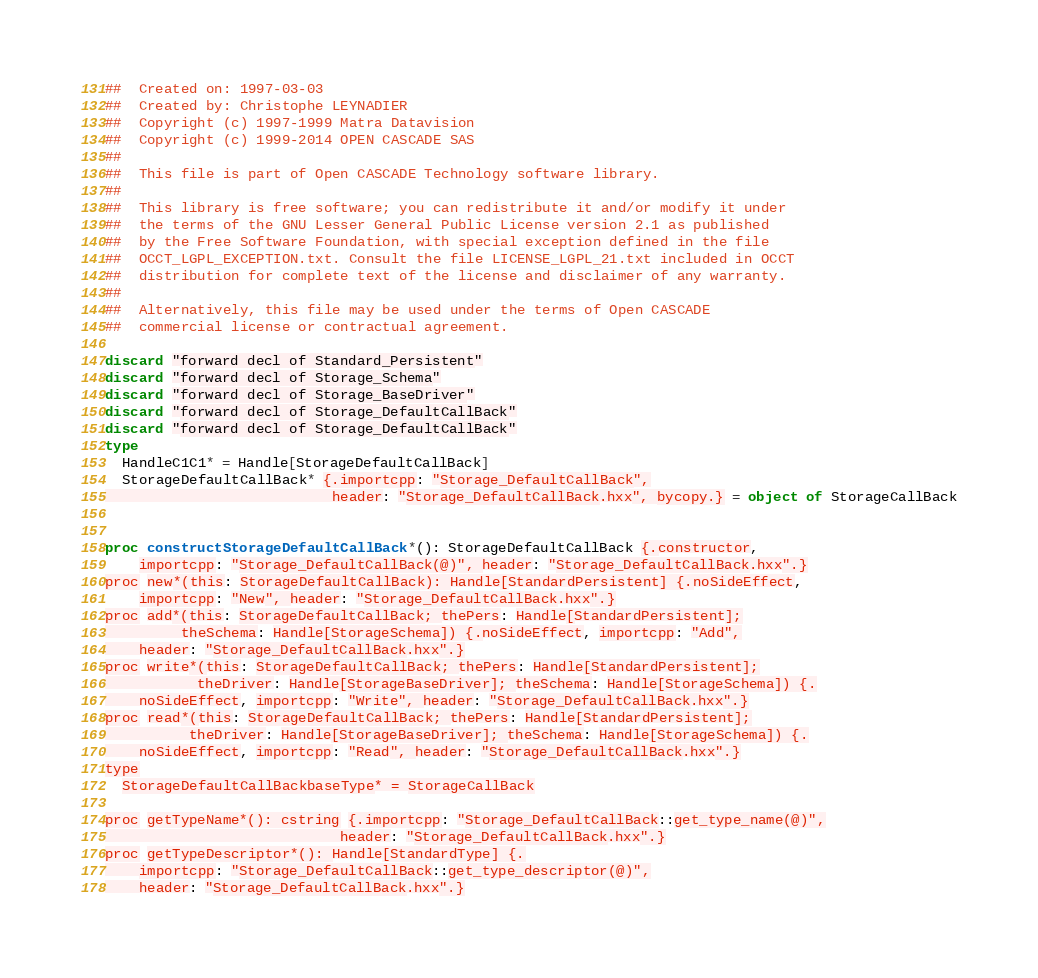<code> <loc_0><loc_0><loc_500><loc_500><_Nim_>##  Created on: 1997-03-03
##  Created by: Christophe LEYNADIER
##  Copyright (c) 1997-1999 Matra Datavision
##  Copyright (c) 1999-2014 OPEN CASCADE SAS
##
##  This file is part of Open CASCADE Technology software library.
##
##  This library is free software; you can redistribute it and/or modify it under
##  the terms of the GNU Lesser General Public License version 2.1 as published
##  by the Free Software Foundation, with special exception defined in the file
##  OCCT_LGPL_EXCEPTION.txt. Consult the file LICENSE_LGPL_21.txt included in OCCT
##  distribution for complete text of the license and disclaimer of any warranty.
##
##  Alternatively, this file may be used under the terms of Open CASCADE
##  commercial license or contractual agreement.

discard "forward decl of Standard_Persistent"
discard "forward decl of Storage_Schema"
discard "forward decl of Storage_BaseDriver"
discard "forward decl of Storage_DefaultCallBack"
discard "forward decl of Storage_DefaultCallBack"
type
  HandleC1C1* = Handle[StorageDefaultCallBack]
  StorageDefaultCallBack* {.importcpp: "Storage_DefaultCallBack",
                           header: "Storage_DefaultCallBack.hxx", bycopy.} = object of StorageCallBack


proc constructStorageDefaultCallBack*(): StorageDefaultCallBack {.constructor,
    importcpp: "Storage_DefaultCallBack(@)", header: "Storage_DefaultCallBack.hxx".}
proc new*(this: StorageDefaultCallBack): Handle[StandardPersistent] {.noSideEffect,
    importcpp: "New", header: "Storage_DefaultCallBack.hxx".}
proc add*(this: StorageDefaultCallBack; thePers: Handle[StandardPersistent];
         theSchema: Handle[StorageSchema]) {.noSideEffect, importcpp: "Add",
    header: "Storage_DefaultCallBack.hxx".}
proc write*(this: StorageDefaultCallBack; thePers: Handle[StandardPersistent];
           theDriver: Handle[StorageBaseDriver]; theSchema: Handle[StorageSchema]) {.
    noSideEffect, importcpp: "Write", header: "Storage_DefaultCallBack.hxx".}
proc read*(this: StorageDefaultCallBack; thePers: Handle[StandardPersistent];
          theDriver: Handle[StorageBaseDriver]; theSchema: Handle[StorageSchema]) {.
    noSideEffect, importcpp: "Read", header: "Storage_DefaultCallBack.hxx".}
type
  StorageDefaultCallBackbaseType* = StorageCallBack

proc getTypeName*(): cstring {.importcpp: "Storage_DefaultCallBack::get_type_name(@)",
                            header: "Storage_DefaultCallBack.hxx".}
proc getTypeDescriptor*(): Handle[StandardType] {.
    importcpp: "Storage_DefaultCallBack::get_type_descriptor(@)",
    header: "Storage_DefaultCallBack.hxx".}</code> 